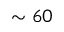Convert formula to latex. <formula><loc_0><loc_0><loc_500><loc_500>\sim 6 0</formula> 